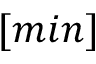Convert formula to latex. <formula><loc_0><loc_0><loc_500><loc_500>[ \min ]</formula> 